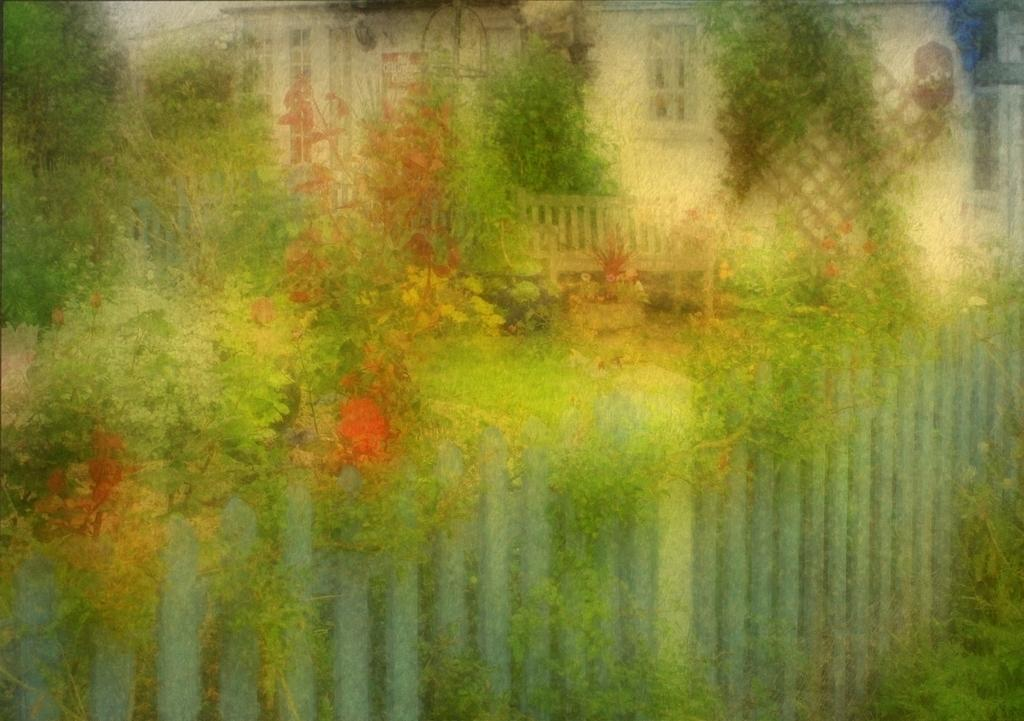How would you describe the quality of the image? The image is blurry. What type of structure can be seen in the image? There is fencing in the image. What type of vegetation is present in the image? There are trees and flowers in the image. What can be seen in the background of the image? There is a building in the background of the image. What type of ground surface is visible in the image? There is grass visible in the image. What type of night activity is taking place in the image? The image does not depict any night activity, as there is no mention of time of day in the provided facts. --- Facts: 1. There is a person sitting on a bench in the image. 2. The person is reading a book. 3. There is a tree behind the bench. 4. There is a pond in front of the bench. 5. There are ducks in the pond. Absurd Topics: parade, elephant, sixth Conversation: What is the person in the image doing? The person is sitting on a bench in the image. What activity is the person engaged in while sitting on the bench? The person is reading a book. What type of vegetation is visible behind the bench? There is a tree behind the bench. What type of water feature is visible in front of the bench? There is a pond in front of the bench. What type of animals can be seen in the pond? There are ducks in the pond. Reasoning: Let's think step by step in order to produce the conversation. We start by identifying the main subject in the image, which is the person sitting on the bench. Then, we expand the conversation to include the person's activity (reading a book) and the surrounding environment (tree, pond, ducks). Each question is designed to elicit a specific detail about the image that is known from the provided facts. Absurd Question/Answer: How many elephants are participating in the parade in the image? There is no parade or elephants present in the image. 